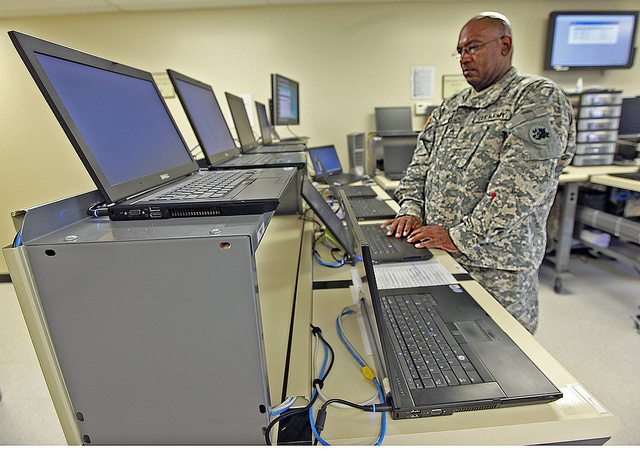Describe the objects in this image and their specific colors. I can see people in tan, gray, darkgray, and black tones, laptop in tan, gray, black, and darkgray tones, laptop in tan, gray, darkgray, and black tones, keyboard in tan, gray, darkgray, and black tones, and tv in tan, darkgray, lightgray, lightblue, and black tones in this image. 